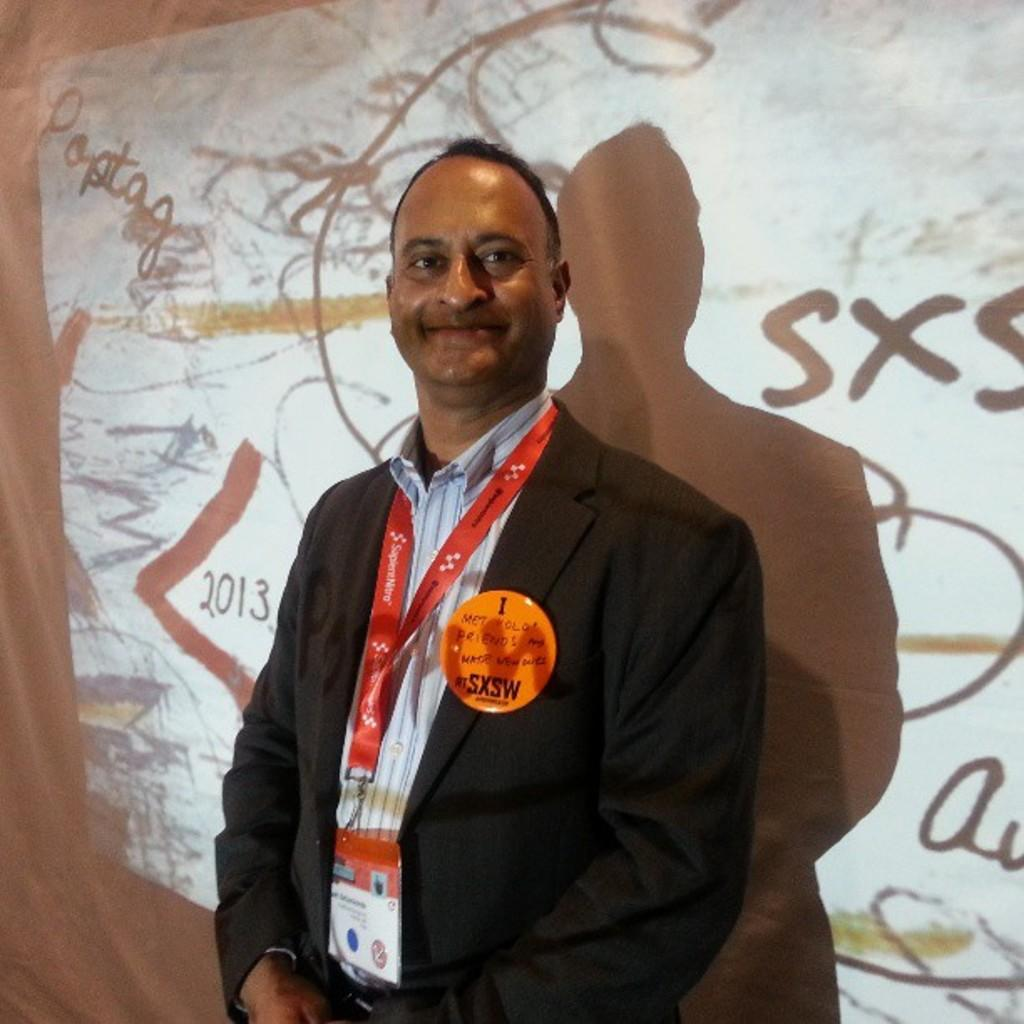Who or what is present in the image? There is a person in the image. What is the person doing or interacting with in the image? The person is in front of a screen. Can you describe the person's attire in the image? The person is wearing clothes. What type of juice is being exchanged on the floor in the image? There is no juice or exchange taking place on the floor in the image. 